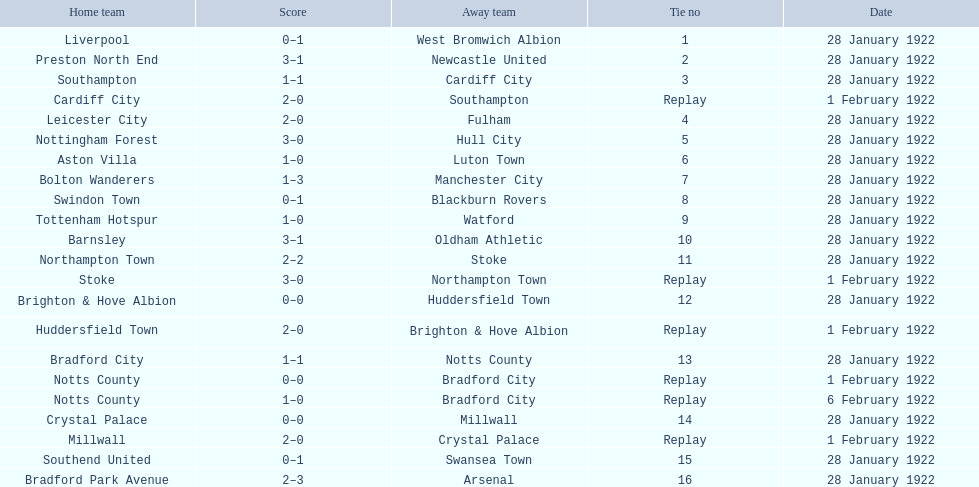What home team had the same score as aston villa on january 28th, 1922? Tottenham Hotspur. 